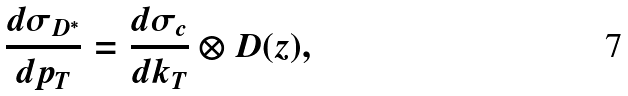Convert formula to latex. <formula><loc_0><loc_0><loc_500><loc_500>\frac { d \sigma _ { D ^ { * } } } { d p _ { T } } = \frac { d \sigma _ { c } } { d k _ { T } } \otimes D ( z ) ,</formula> 